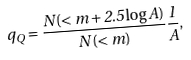Convert formula to latex. <formula><loc_0><loc_0><loc_500><loc_500>q _ { Q } = \frac { N ( < m + 2 . 5 \log A ) } { N ( < m ) } \frac { 1 } { A } ,</formula> 